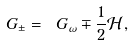Convert formula to latex. <formula><loc_0><loc_0><loc_500><loc_500>\ G _ { \pm } = \ G _ { \omega } \mp \frac { 1 } { 2 } \mathcal { H } ,</formula> 